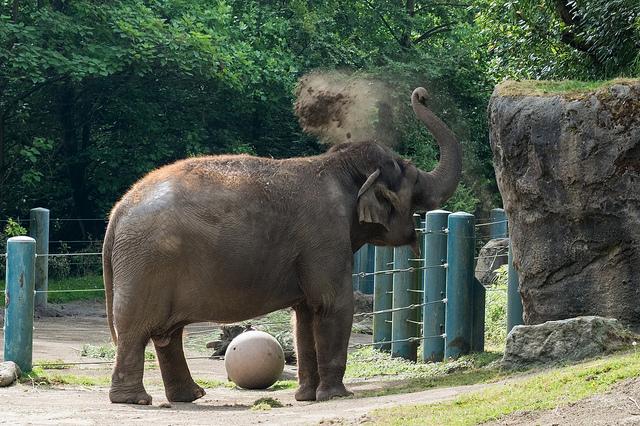What color are the fence posts?
Short answer required. Blue. What is the elephant doing?
Write a very short answer. Standing. What shape object is the elephant playing with?
Keep it brief. Round. Why is the elephant tossing dirt on itself?
Write a very short answer. To cool off. What toy has the elephant been given?
Answer briefly. Ball. 